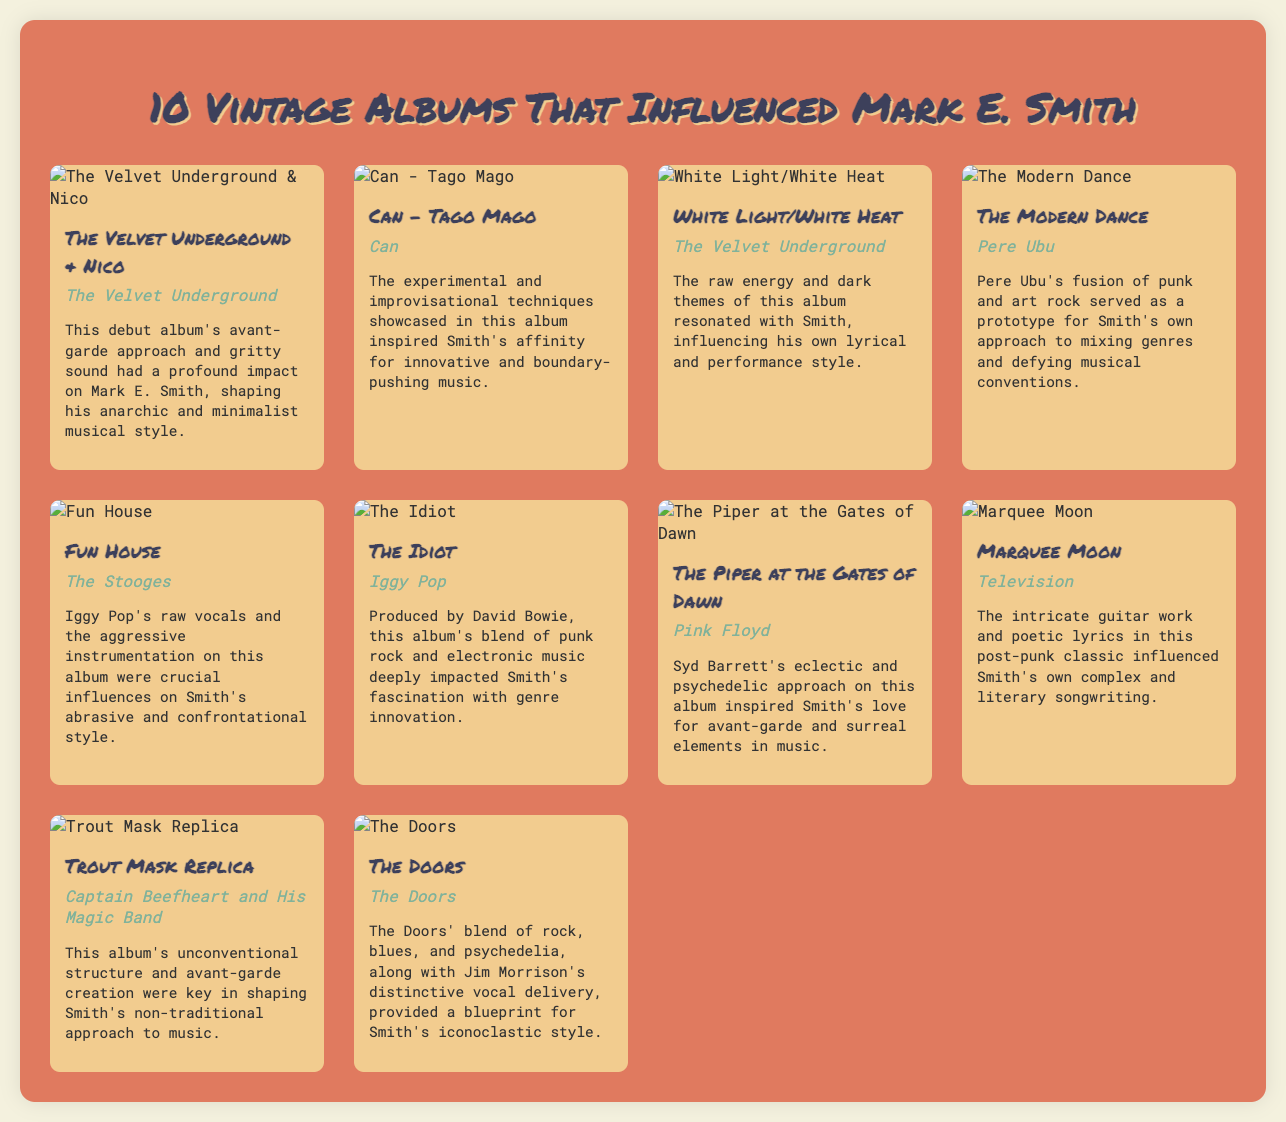what is the title of the first album listed? The first album in the list is identified by its title in the document.
Answer: The Velvet Underground & Nico who is the artist of the album "Marquee Moon"? The document provides the artist's name associated with "Marquee Moon".
Answer: Television how many albums are listed in total? The document states that it features 10 vintage albums.
Answer: 10 which album is credited to Iggy Pop? The document names the album by Iggy Pop, which is listed among the influences.
Answer: The Idiot what genre does "The Modern Dance" represent? The document describes this album as a mix of punk and art rock.
Answer: Punk and art rock which album influenced Mark E. Smith's lyrical style? The document notes that "White Light/White Heat" resonated with Smith and influenced his lyrics.
Answer: White Light/White Heat who produced "The Idiot"? The document specifies the producer of "The Idiot".
Answer: David Bowie which album features Syd Barrett's psychedelic approach? The document indicates which album demonstrates Syd Barrett's unique style.
Answer: The Piper at the Gates of Dawn 